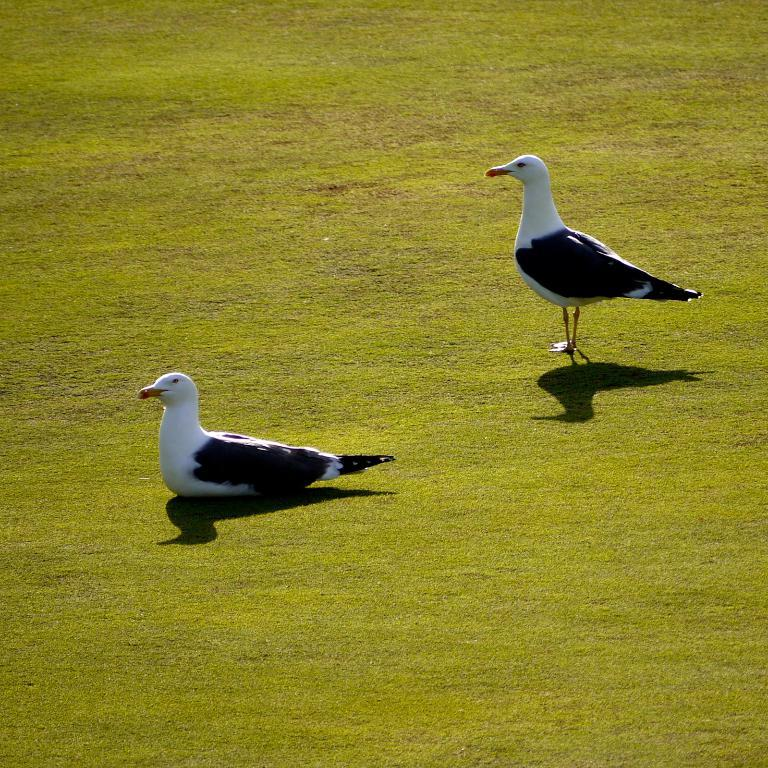What type of animals can be seen in the image? There are birds in the image. Where are the birds located? The birds are on the grass. What type of cherry is being used to increase the size of the birds in the image? There is no cherry present in the image, and the birds' size is not being altered. 